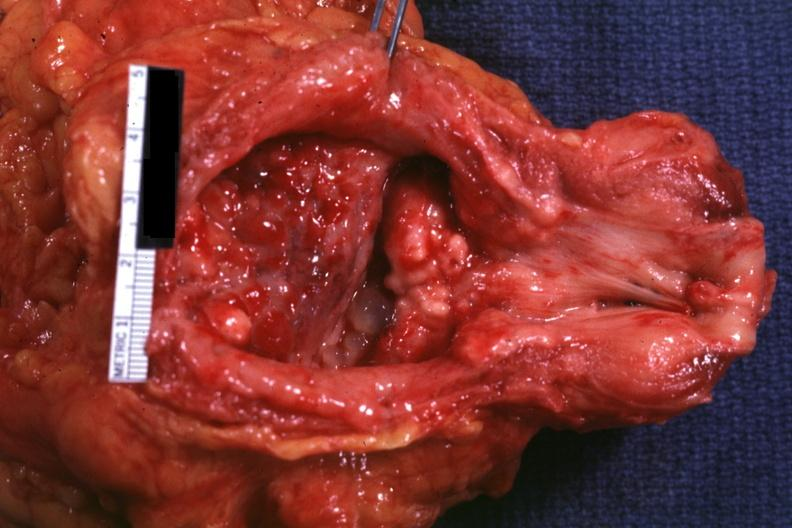what is present?
Answer the question using a single word or phrase. Adenocarcinoma 